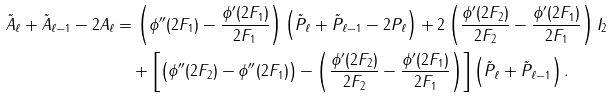<formula> <loc_0><loc_0><loc_500><loc_500>\tilde { A } _ { \ell } + \tilde { A } _ { \ell - 1 } - 2 A _ { \ell } & = \left ( \phi ^ { \prime \prime } ( 2 F _ { 1 } ) - \frac { \phi ^ { \prime } ( 2 F _ { 1 } ) } { 2 F _ { 1 } } \right ) \left ( \tilde { P } _ { \ell } + \tilde { P } _ { \ell - 1 } - 2 P _ { \ell } \right ) + 2 \left ( \frac { \phi ^ { \prime } ( 2 F _ { 2 } ) } { 2 F _ { 2 } } - \frac { \phi ^ { \prime } ( 2 F _ { 1 } ) } { 2 F _ { 1 } } \right ) I _ { 2 } \\ & \quad + \left [ \left ( \phi ^ { \prime \prime } ( 2 F _ { 2 } ) - \phi ^ { \prime \prime } ( 2 F _ { 1 } ) \right ) - \left ( \frac { \phi ^ { \prime } ( 2 F _ { 2 } ) } { 2 F _ { 2 } } - \frac { \phi ^ { \prime } ( 2 F _ { 1 } ) } { 2 F _ { 1 } } \right ) \right ] \left ( \tilde { P } _ { \ell } + \tilde { P } _ { \ell - 1 } \right ) .</formula> 